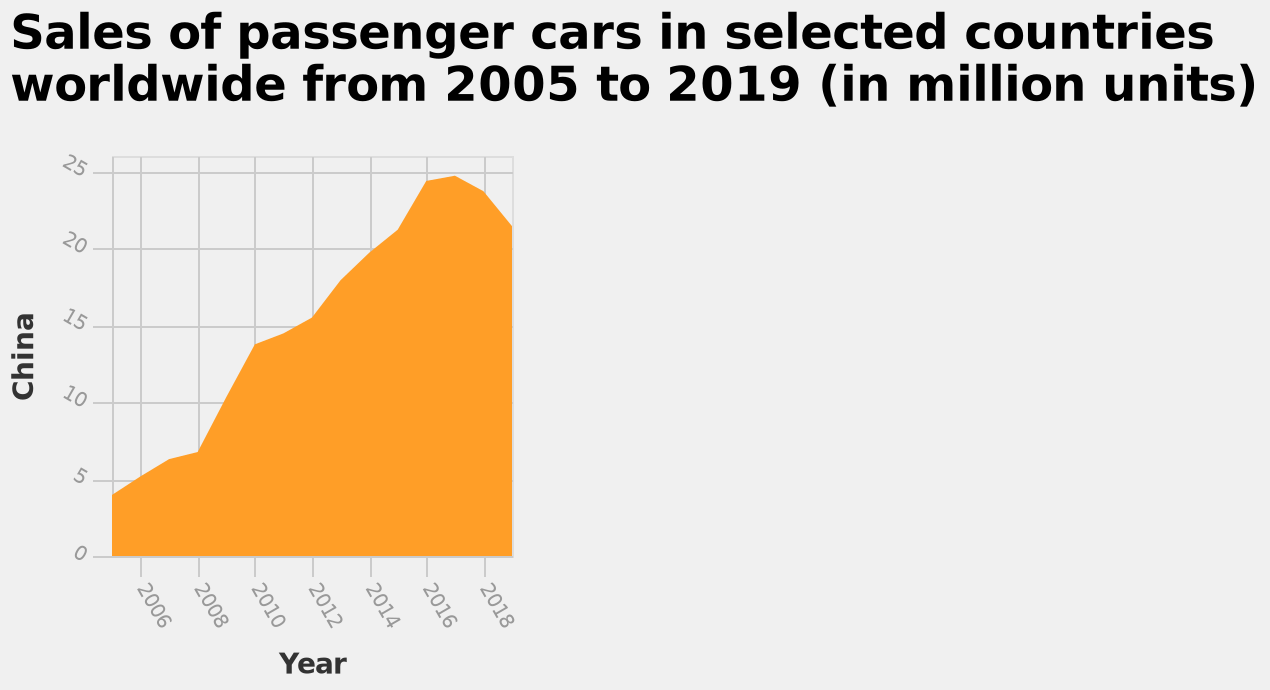<image>
What does the y-axis measure?  The y-axis measures the sales of passenger cars in China. What is the range on the x-axis of the area plot?  The x-axis of the area plot ranges from 2006 to 2018. What was the overall trend in car sales in China between 2006 and 2019? There was a steady increase in car sales between 2006 and 2017 but a drop between 2017 and 2019. What is the maximum value on the y-axis? The maximum value on the y-axis is 25. 